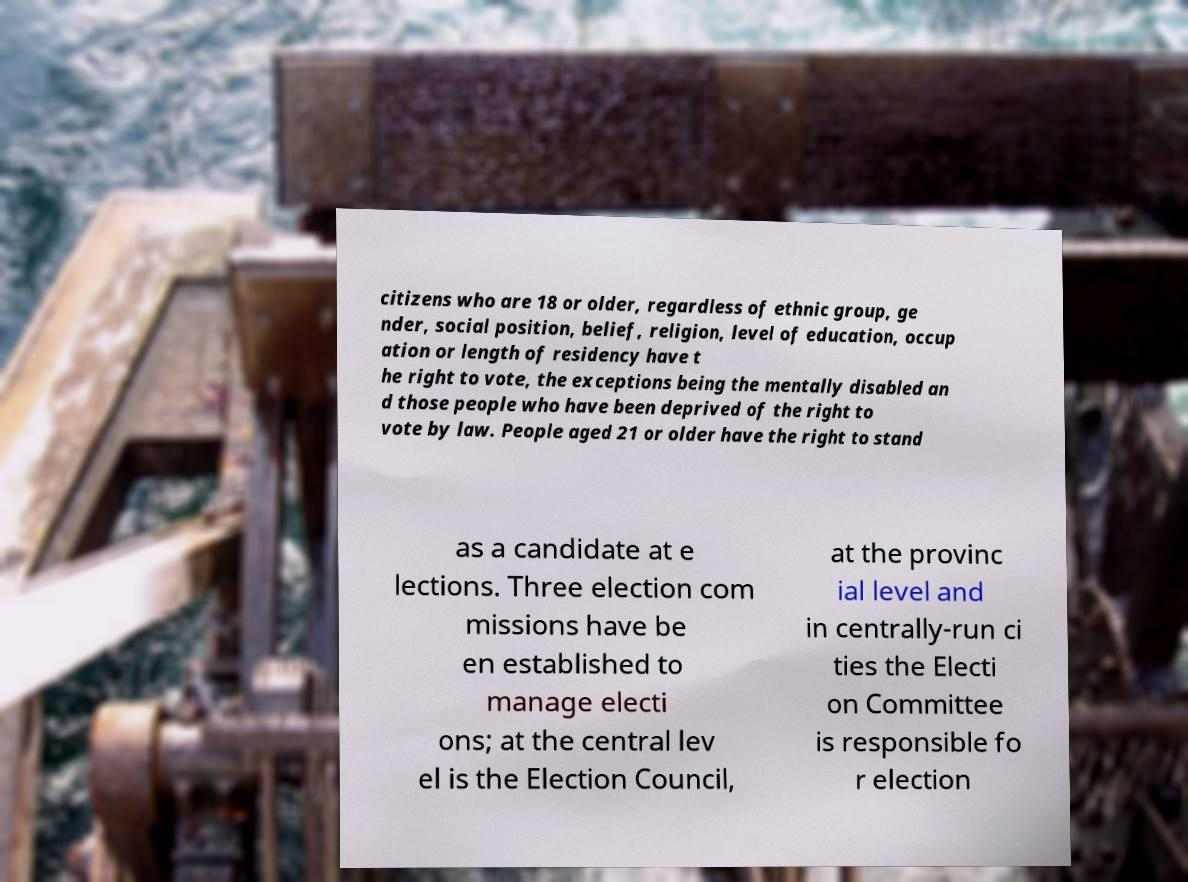Please read and relay the text visible in this image. What does it say? citizens who are 18 or older, regardless of ethnic group, ge nder, social position, belief, religion, level of education, occup ation or length of residency have t he right to vote, the exceptions being the mentally disabled an d those people who have been deprived of the right to vote by law. People aged 21 or older have the right to stand as a candidate at e lections. Three election com missions have be en established to manage electi ons; at the central lev el is the Election Council, at the provinc ial level and in centrally-run ci ties the Electi on Committee is responsible fo r election 